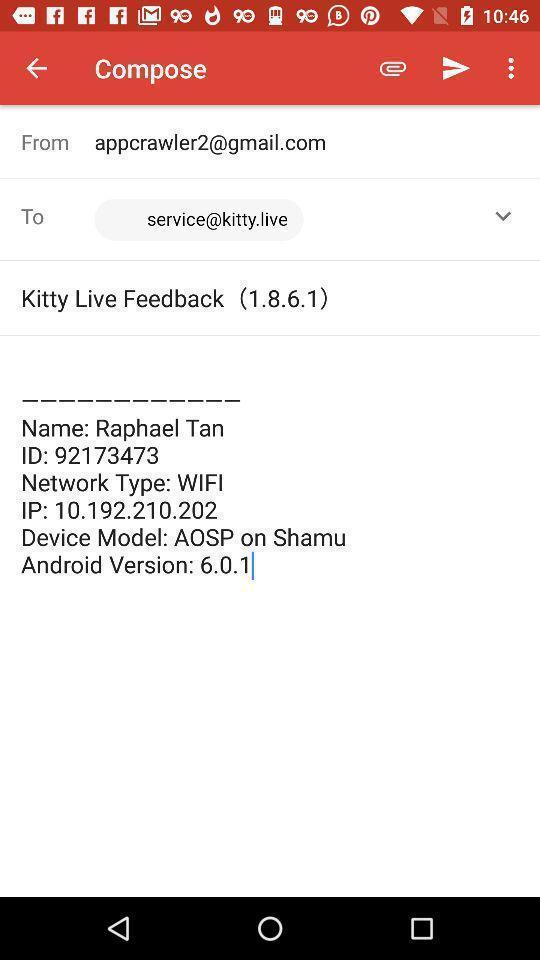What can you discern from this picture? Screen displaying the compose page of a mail app. 